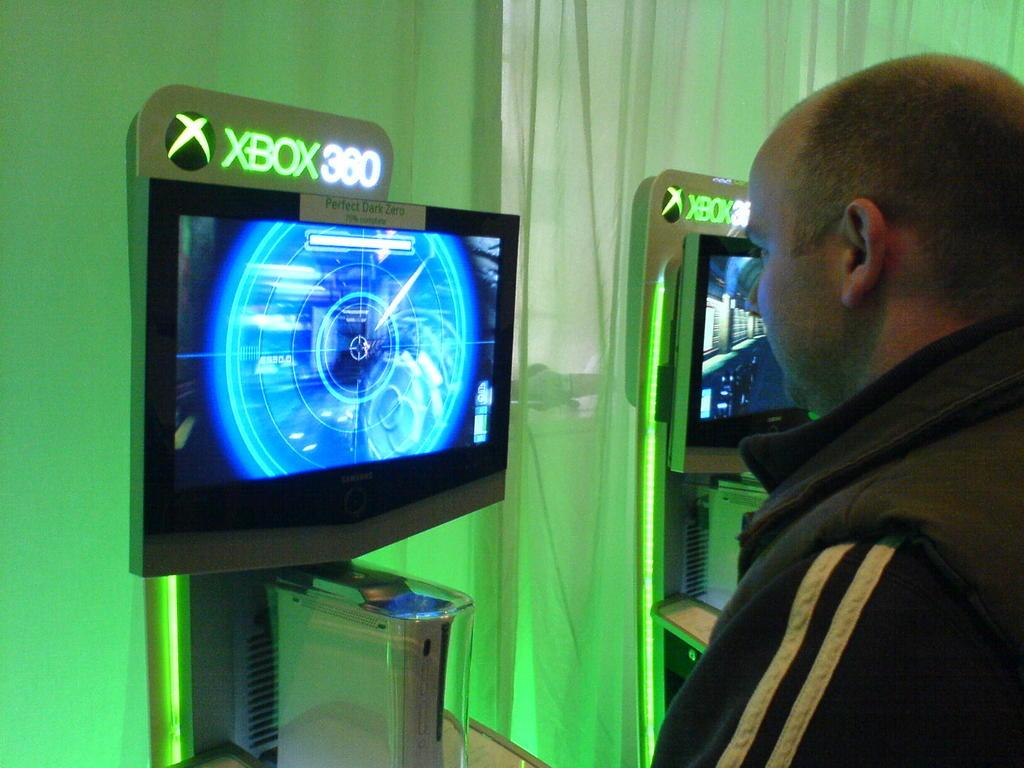<image>
Render a clear and concise summary of the photo. A man watching a screen with xbox 360 on top. 